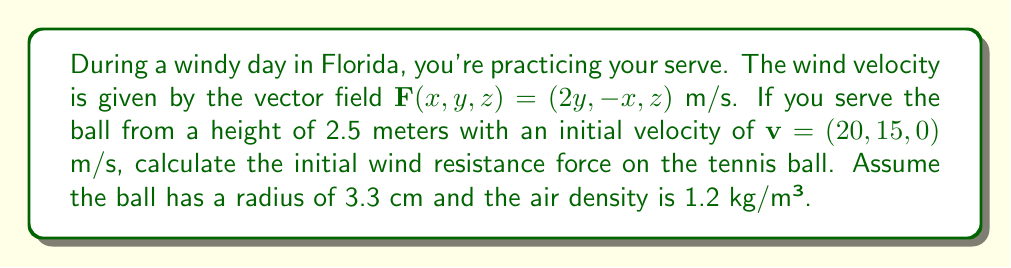Show me your answer to this math problem. Let's approach this step-by-step:

1) First, we need to calculate the relative velocity of the ball with respect to the wind. At the initial position (0, 0, 2.5):

   $\mathbf{v}_{\text{rel}} = \mathbf{v} - \mathbf{F}(0,0,2.5) = (20, 15, 0) - (0, 0, 2.5) = (20, 15, -2.5)$ m/s

2) The magnitude of the relative velocity:

   $|\mathbf{v}_{\text{rel}}| = \sqrt{20^2 + 15^2 + (-2.5)^2} \approx 25.25$ m/s

3) The drag force is given by the formula:

   $\mathbf{F}_d = -\frac{1}{2} C_d \rho A |\mathbf{v}_{\text{rel}}| \mathbf{v}_{\text{rel}}$

   Where:
   - $C_d$ is the drag coefficient (approximately 0.5 for a sphere)
   - $\rho$ is the air density (1.2 kg/m³)
   - $A$ is the cross-sectional area of the ball ($\pi r^2$)

4) Calculate the cross-sectional area:

   $A = \pi (0.033)^2 \approx 0.00342$ m²

5) Now we can calculate the magnitude of the drag force:

   $|\mathbf{F}_d| = \frac{1}{2} \cdot 0.5 \cdot 1.2 \cdot 0.00342 \cdot 25.25^2 \approx 0.327$ N

6) The direction of the force is opposite to the relative velocity, so:

   $\mathbf{F}_d = -0.327 \cdot \frac{\mathbf{v}_{\text{rel}}}{|\mathbf{v}_{\text{rel}}|}$

   $= -0.327 \cdot \frac{(20, 15, -2.5)}{25.25}$

   $\approx (-0.259, -0.194, 0.032)$ N
Answer: $(-0.259, -0.194, 0.032)$ N 